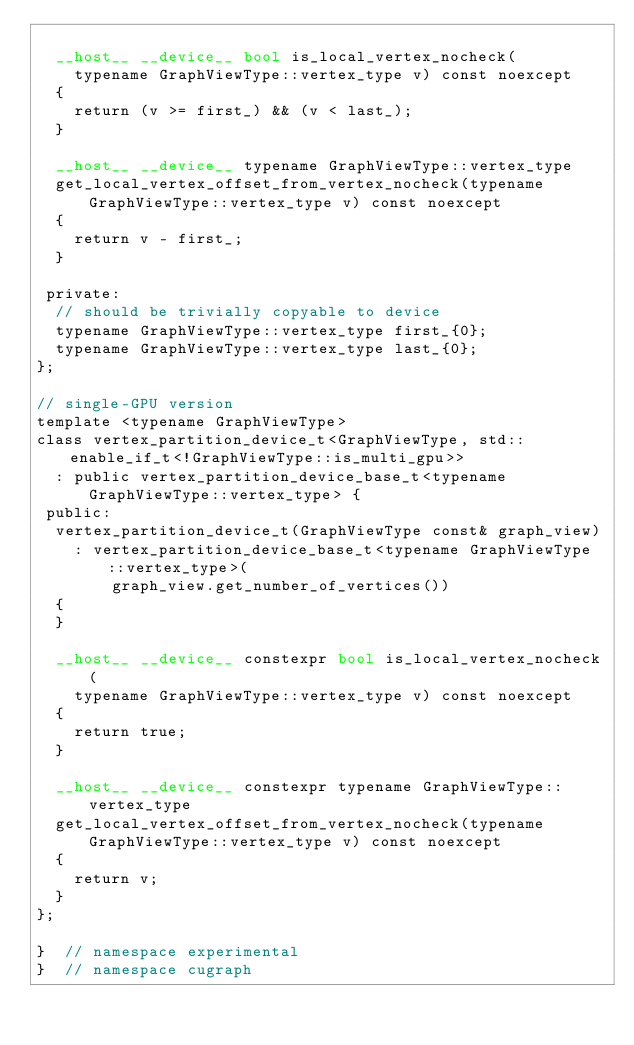Convert code to text. <code><loc_0><loc_0><loc_500><loc_500><_Cuda_>
  __host__ __device__ bool is_local_vertex_nocheck(
    typename GraphViewType::vertex_type v) const noexcept
  {
    return (v >= first_) && (v < last_);
  }

  __host__ __device__ typename GraphViewType::vertex_type
  get_local_vertex_offset_from_vertex_nocheck(typename GraphViewType::vertex_type v) const noexcept
  {
    return v - first_;
  }

 private:
  // should be trivially copyable to device
  typename GraphViewType::vertex_type first_{0};
  typename GraphViewType::vertex_type last_{0};
};

// single-GPU version
template <typename GraphViewType>
class vertex_partition_device_t<GraphViewType, std::enable_if_t<!GraphViewType::is_multi_gpu>>
  : public vertex_partition_device_base_t<typename GraphViewType::vertex_type> {
 public:
  vertex_partition_device_t(GraphViewType const& graph_view)
    : vertex_partition_device_base_t<typename GraphViewType::vertex_type>(
        graph_view.get_number_of_vertices())
  {
  }

  __host__ __device__ constexpr bool is_local_vertex_nocheck(
    typename GraphViewType::vertex_type v) const noexcept
  {
    return true;
  }

  __host__ __device__ constexpr typename GraphViewType::vertex_type
  get_local_vertex_offset_from_vertex_nocheck(typename GraphViewType::vertex_type v) const noexcept
  {
    return v;
  }
};

}  // namespace experimental
}  // namespace cugraph
</code> 